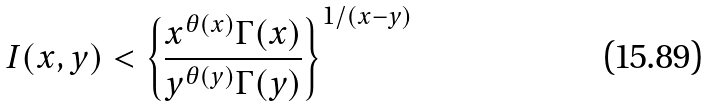Convert formula to latex. <formula><loc_0><loc_0><loc_500><loc_500>I ( x , y ) < \left \{ \frac { x ^ { \theta ( x ) } \Gamma ( x ) } { y ^ { \theta ( y ) } \Gamma ( y ) } \right \} ^ { 1 / ( x - y ) }</formula> 